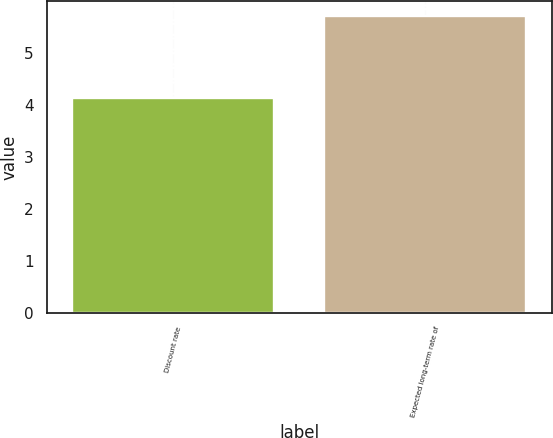<chart> <loc_0><loc_0><loc_500><loc_500><bar_chart><fcel>Discount rate<fcel>Expected long-term rate of<nl><fcel>4.12<fcel>5.7<nl></chart> 